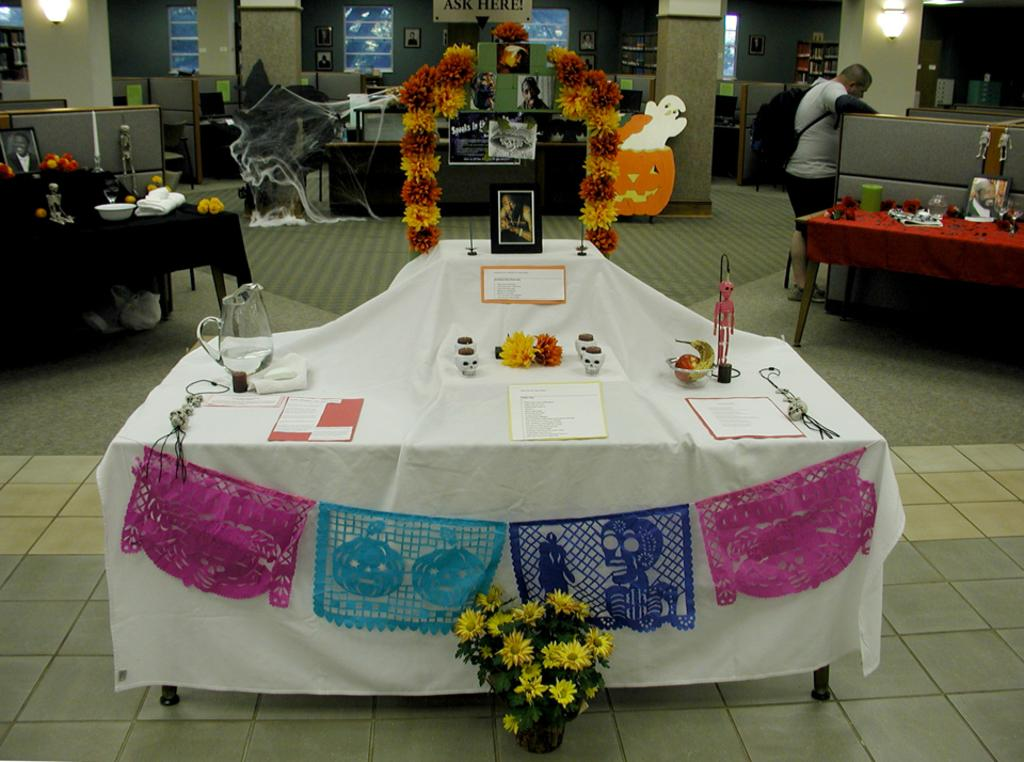What is the main setting of the image? There is a room in the image. What piece of furniture is present in the room? There is a table in the room. What items can be seen on the table? There is a jar, paper, a poster, and photo frames on the table. Can you describe the person in the image? There is a person on the right side of the image, and they are wearing a bag. What type of pear is being used as a hat in the image? There is no pear or hat present in the image. 